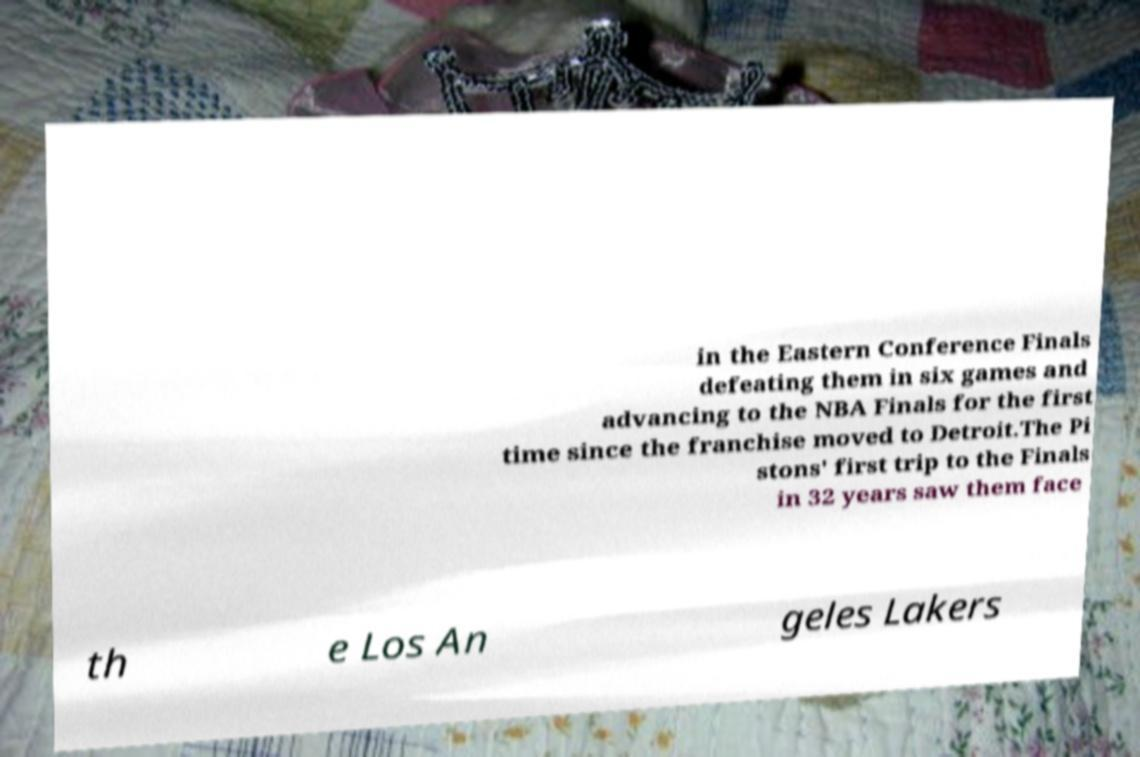Please identify and transcribe the text found in this image. in the Eastern Conference Finals defeating them in six games and advancing to the NBA Finals for the first time since the franchise moved to Detroit.The Pi stons' first trip to the Finals in 32 years saw them face th e Los An geles Lakers 